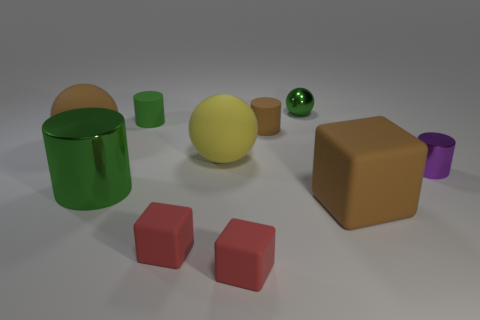Subtract 1 cylinders. How many cylinders are left? 3 Subtract all cubes. How many objects are left? 7 Subtract 1 purple cylinders. How many objects are left? 9 Subtract all big yellow spheres. Subtract all big green objects. How many objects are left? 8 Add 7 purple metallic cylinders. How many purple metallic cylinders are left? 8 Add 8 rubber cylinders. How many rubber cylinders exist? 10 